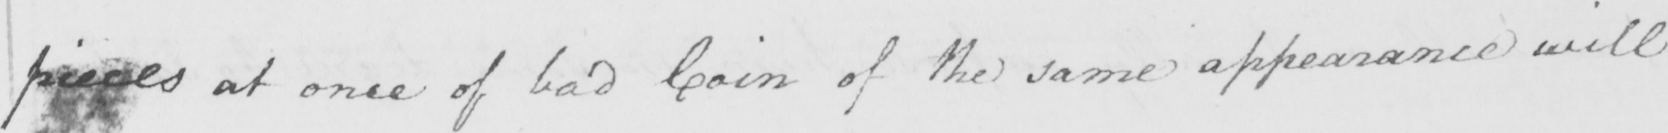What text is written in this handwritten line? pieces at once of bad Coin of the same appearance will 